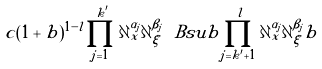<formula> <loc_0><loc_0><loc_500><loc_500>c ( 1 + b ) ^ { 1 - l } \prod _ { j = 1 } ^ { k ^ { \prime } } \partial _ { x } ^ { \alpha _ { j } } \partial _ { \xi } ^ { \beta _ { j } } \ B s u b \prod _ { j = k ^ { \prime } + 1 } ^ { l } \partial _ { x } ^ { \alpha _ { j } } \partial _ { \xi } ^ { \beta _ { j } } b</formula> 